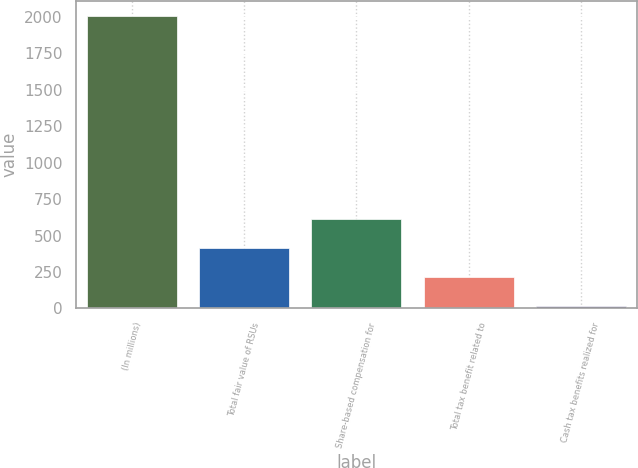<chart> <loc_0><loc_0><loc_500><loc_500><bar_chart><fcel>(In millions)<fcel>Total fair value of RSUs<fcel>Share-based compensation for<fcel>Total tax benefit related to<fcel>Cash tax benefits realized for<nl><fcel>2009<fcel>413<fcel>612.5<fcel>213.5<fcel>14<nl></chart> 